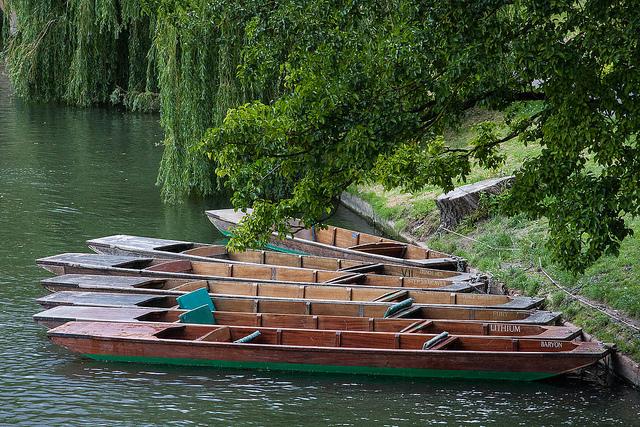What color paint is used to put names on the boats?
Write a very short answer. White. Could these boats be rentals?
Write a very short answer. Yes. How many bottles are visible?
Give a very brief answer. 0. 